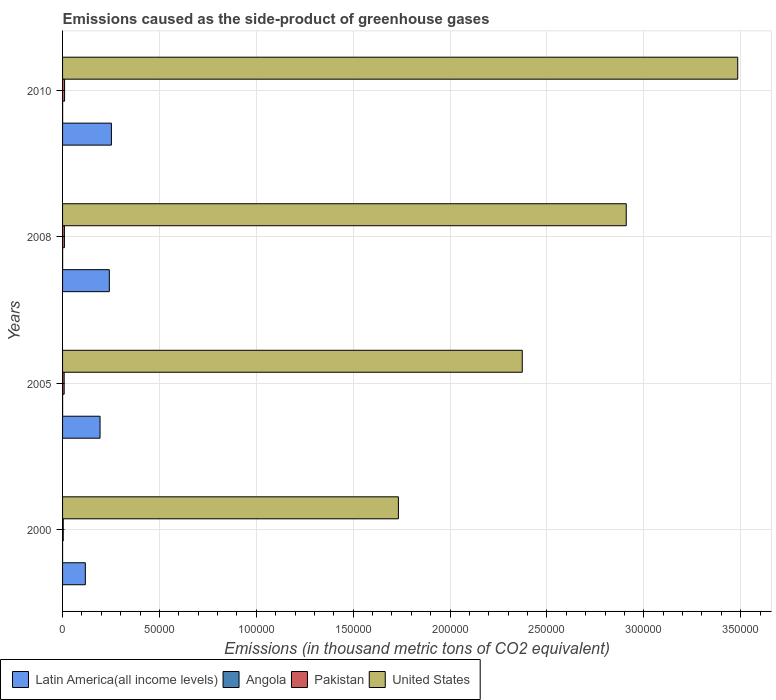What is the emissions caused as the side-product of greenhouse gases in Angola in 2005?
Your response must be concise. 19.3. Across all years, what is the maximum emissions caused as the side-product of greenhouse gases in Latin America(all income levels)?
Make the answer very short. 2.52e+04. Across all years, what is the minimum emissions caused as the side-product of greenhouse gases in Pakistan?
Your answer should be very brief. 347.2. In which year was the emissions caused as the side-product of greenhouse gases in Pakistan maximum?
Keep it short and to the point. 2010. In which year was the emissions caused as the side-product of greenhouse gases in Pakistan minimum?
Ensure brevity in your answer.  2000. What is the total emissions caused as the side-product of greenhouse gases in Pakistan in the graph?
Your answer should be compact. 3154.2. What is the difference between the emissions caused as the side-product of greenhouse gases in United States in 2005 and that in 2008?
Give a very brief answer. -5.37e+04. What is the difference between the emissions caused as the side-product of greenhouse gases in Angola in 2000 and the emissions caused as the side-product of greenhouse gases in Pakistan in 2008?
Your answer should be compact. -950.9. What is the average emissions caused as the side-product of greenhouse gases in Latin America(all income levels) per year?
Your answer should be compact. 2.01e+04. In the year 2000, what is the difference between the emissions caused as the side-product of greenhouse gases in Latin America(all income levels) and emissions caused as the side-product of greenhouse gases in United States?
Ensure brevity in your answer.  -1.62e+05. In how many years, is the emissions caused as the side-product of greenhouse gases in Pakistan greater than 320000 thousand metric tons?
Offer a terse response. 0. What is the ratio of the emissions caused as the side-product of greenhouse gases in Angola in 2000 to that in 2008?
Keep it short and to the point. 0.03. What is the difference between the highest and the second highest emissions caused as the side-product of greenhouse gases in Pakistan?
Ensure brevity in your answer.  84.4. What is the difference between the highest and the lowest emissions caused as the side-product of greenhouse gases in Pakistan?
Your answer should be very brief. 688.8. Is it the case that in every year, the sum of the emissions caused as the side-product of greenhouse gases in Angola and emissions caused as the side-product of greenhouse gases in Latin America(all income levels) is greater than the sum of emissions caused as the side-product of greenhouse gases in Pakistan and emissions caused as the side-product of greenhouse gases in United States?
Offer a very short reply. No. What does the 1st bar from the top in 2010 represents?
Your response must be concise. United States. What does the 4th bar from the bottom in 2010 represents?
Give a very brief answer. United States. How many bars are there?
Your response must be concise. 16. How many years are there in the graph?
Give a very brief answer. 4. What is the difference between two consecutive major ticks on the X-axis?
Your answer should be compact. 5.00e+04. Does the graph contain any zero values?
Make the answer very short. No. Does the graph contain grids?
Provide a succinct answer. Yes. How are the legend labels stacked?
Provide a succinct answer. Horizontal. What is the title of the graph?
Your answer should be very brief. Emissions caused as the side-product of greenhouse gases. What is the label or title of the X-axis?
Your response must be concise. Emissions (in thousand metric tons of CO2 equivalent). What is the label or title of the Y-axis?
Your answer should be very brief. Years. What is the Emissions (in thousand metric tons of CO2 equivalent) of Latin America(all income levels) in 2000?
Your answer should be compact. 1.18e+04. What is the Emissions (in thousand metric tons of CO2 equivalent) in Pakistan in 2000?
Provide a short and direct response. 347.2. What is the Emissions (in thousand metric tons of CO2 equivalent) of United States in 2000?
Your answer should be compact. 1.73e+05. What is the Emissions (in thousand metric tons of CO2 equivalent) in Latin America(all income levels) in 2005?
Keep it short and to the point. 1.93e+04. What is the Emissions (in thousand metric tons of CO2 equivalent) of Angola in 2005?
Provide a succinct answer. 19.3. What is the Emissions (in thousand metric tons of CO2 equivalent) in Pakistan in 2005?
Give a very brief answer. 819.4. What is the Emissions (in thousand metric tons of CO2 equivalent) in United States in 2005?
Provide a short and direct response. 2.37e+05. What is the Emissions (in thousand metric tons of CO2 equivalent) of Latin America(all income levels) in 2008?
Ensure brevity in your answer.  2.41e+04. What is the Emissions (in thousand metric tons of CO2 equivalent) in Pakistan in 2008?
Offer a very short reply. 951.6. What is the Emissions (in thousand metric tons of CO2 equivalent) in United States in 2008?
Ensure brevity in your answer.  2.91e+05. What is the Emissions (in thousand metric tons of CO2 equivalent) of Latin America(all income levels) in 2010?
Provide a succinct answer. 2.52e+04. What is the Emissions (in thousand metric tons of CO2 equivalent) in Pakistan in 2010?
Your response must be concise. 1036. What is the Emissions (in thousand metric tons of CO2 equivalent) in United States in 2010?
Your answer should be very brief. 3.48e+05. Across all years, what is the maximum Emissions (in thousand metric tons of CO2 equivalent) in Latin America(all income levels)?
Give a very brief answer. 2.52e+04. Across all years, what is the maximum Emissions (in thousand metric tons of CO2 equivalent) in Pakistan?
Ensure brevity in your answer.  1036. Across all years, what is the maximum Emissions (in thousand metric tons of CO2 equivalent) of United States?
Keep it short and to the point. 3.48e+05. Across all years, what is the minimum Emissions (in thousand metric tons of CO2 equivalent) of Latin America(all income levels)?
Your answer should be very brief. 1.18e+04. Across all years, what is the minimum Emissions (in thousand metric tons of CO2 equivalent) in Pakistan?
Your answer should be very brief. 347.2. Across all years, what is the minimum Emissions (in thousand metric tons of CO2 equivalent) in United States?
Make the answer very short. 1.73e+05. What is the total Emissions (in thousand metric tons of CO2 equivalent) of Latin America(all income levels) in the graph?
Provide a short and direct response. 8.04e+04. What is the total Emissions (in thousand metric tons of CO2 equivalent) of Angola in the graph?
Give a very brief answer. 77.5. What is the total Emissions (in thousand metric tons of CO2 equivalent) in Pakistan in the graph?
Ensure brevity in your answer.  3154.2. What is the total Emissions (in thousand metric tons of CO2 equivalent) of United States in the graph?
Give a very brief answer. 1.05e+06. What is the difference between the Emissions (in thousand metric tons of CO2 equivalent) of Latin America(all income levels) in 2000 and that in 2005?
Ensure brevity in your answer.  -7590.8. What is the difference between the Emissions (in thousand metric tons of CO2 equivalent) of Angola in 2000 and that in 2005?
Offer a terse response. -18.6. What is the difference between the Emissions (in thousand metric tons of CO2 equivalent) in Pakistan in 2000 and that in 2005?
Provide a short and direct response. -472.2. What is the difference between the Emissions (in thousand metric tons of CO2 equivalent) in United States in 2000 and that in 2005?
Offer a terse response. -6.39e+04. What is the difference between the Emissions (in thousand metric tons of CO2 equivalent) of Latin America(all income levels) in 2000 and that in 2008?
Keep it short and to the point. -1.24e+04. What is the difference between the Emissions (in thousand metric tons of CO2 equivalent) of Angola in 2000 and that in 2008?
Give a very brief answer. -25.8. What is the difference between the Emissions (in thousand metric tons of CO2 equivalent) in Pakistan in 2000 and that in 2008?
Provide a short and direct response. -604.4. What is the difference between the Emissions (in thousand metric tons of CO2 equivalent) in United States in 2000 and that in 2008?
Your response must be concise. -1.18e+05. What is the difference between the Emissions (in thousand metric tons of CO2 equivalent) in Latin America(all income levels) in 2000 and that in 2010?
Your answer should be compact. -1.34e+04. What is the difference between the Emissions (in thousand metric tons of CO2 equivalent) of Angola in 2000 and that in 2010?
Give a very brief answer. -30.3. What is the difference between the Emissions (in thousand metric tons of CO2 equivalent) of Pakistan in 2000 and that in 2010?
Your answer should be very brief. -688.8. What is the difference between the Emissions (in thousand metric tons of CO2 equivalent) in United States in 2000 and that in 2010?
Offer a terse response. -1.75e+05. What is the difference between the Emissions (in thousand metric tons of CO2 equivalent) of Latin America(all income levels) in 2005 and that in 2008?
Offer a very short reply. -4793.3. What is the difference between the Emissions (in thousand metric tons of CO2 equivalent) in Angola in 2005 and that in 2008?
Give a very brief answer. -7.2. What is the difference between the Emissions (in thousand metric tons of CO2 equivalent) in Pakistan in 2005 and that in 2008?
Give a very brief answer. -132.2. What is the difference between the Emissions (in thousand metric tons of CO2 equivalent) in United States in 2005 and that in 2008?
Offer a terse response. -5.37e+04. What is the difference between the Emissions (in thousand metric tons of CO2 equivalent) of Latin America(all income levels) in 2005 and that in 2010?
Provide a short and direct response. -5858.9. What is the difference between the Emissions (in thousand metric tons of CO2 equivalent) of Angola in 2005 and that in 2010?
Keep it short and to the point. -11.7. What is the difference between the Emissions (in thousand metric tons of CO2 equivalent) in Pakistan in 2005 and that in 2010?
Offer a terse response. -216.6. What is the difference between the Emissions (in thousand metric tons of CO2 equivalent) of United States in 2005 and that in 2010?
Your answer should be compact. -1.11e+05. What is the difference between the Emissions (in thousand metric tons of CO2 equivalent) of Latin America(all income levels) in 2008 and that in 2010?
Your response must be concise. -1065.6. What is the difference between the Emissions (in thousand metric tons of CO2 equivalent) of Angola in 2008 and that in 2010?
Make the answer very short. -4.5. What is the difference between the Emissions (in thousand metric tons of CO2 equivalent) in Pakistan in 2008 and that in 2010?
Give a very brief answer. -84.4. What is the difference between the Emissions (in thousand metric tons of CO2 equivalent) in United States in 2008 and that in 2010?
Your answer should be very brief. -5.75e+04. What is the difference between the Emissions (in thousand metric tons of CO2 equivalent) in Latin America(all income levels) in 2000 and the Emissions (in thousand metric tons of CO2 equivalent) in Angola in 2005?
Your answer should be compact. 1.17e+04. What is the difference between the Emissions (in thousand metric tons of CO2 equivalent) of Latin America(all income levels) in 2000 and the Emissions (in thousand metric tons of CO2 equivalent) of Pakistan in 2005?
Give a very brief answer. 1.09e+04. What is the difference between the Emissions (in thousand metric tons of CO2 equivalent) in Latin America(all income levels) in 2000 and the Emissions (in thousand metric tons of CO2 equivalent) in United States in 2005?
Give a very brief answer. -2.25e+05. What is the difference between the Emissions (in thousand metric tons of CO2 equivalent) in Angola in 2000 and the Emissions (in thousand metric tons of CO2 equivalent) in Pakistan in 2005?
Offer a very short reply. -818.7. What is the difference between the Emissions (in thousand metric tons of CO2 equivalent) in Angola in 2000 and the Emissions (in thousand metric tons of CO2 equivalent) in United States in 2005?
Give a very brief answer. -2.37e+05. What is the difference between the Emissions (in thousand metric tons of CO2 equivalent) of Pakistan in 2000 and the Emissions (in thousand metric tons of CO2 equivalent) of United States in 2005?
Make the answer very short. -2.37e+05. What is the difference between the Emissions (in thousand metric tons of CO2 equivalent) of Latin America(all income levels) in 2000 and the Emissions (in thousand metric tons of CO2 equivalent) of Angola in 2008?
Your answer should be very brief. 1.17e+04. What is the difference between the Emissions (in thousand metric tons of CO2 equivalent) of Latin America(all income levels) in 2000 and the Emissions (in thousand metric tons of CO2 equivalent) of Pakistan in 2008?
Your response must be concise. 1.08e+04. What is the difference between the Emissions (in thousand metric tons of CO2 equivalent) in Latin America(all income levels) in 2000 and the Emissions (in thousand metric tons of CO2 equivalent) in United States in 2008?
Provide a succinct answer. -2.79e+05. What is the difference between the Emissions (in thousand metric tons of CO2 equivalent) of Angola in 2000 and the Emissions (in thousand metric tons of CO2 equivalent) of Pakistan in 2008?
Give a very brief answer. -950.9. What is the difference between the Emissions (in thousand metric tons of CO2 equivalent) in Angola in 2000 and the Emissions (in thousand metric tons of CO2 equivalent) in United States in 2008?
Give a very brief answer. -2.91e+05. What is the difference between the Emissions (in thousand metric tons of CO2 equivalent) in Pakistan in 2000 and the Emissions (in thousand metric tons of CO2 equivalent) in United States in 2008?
Provide a succinct answer. -2.91e+05. What is the difference between the Emissions (in thousand metric tons of CO2 equivalent) of Latin America(all income levels) in 2000 and the Emissions (in thousand metric tons of CO2 equivalent) of Angola in 2010?
Ensure brevity in your answer.  1.17e+04. What is the difference between the Emissions (in thousand metric tons of CO2 equivalent) of Latin America(all income levels) in 2000 and the Emissions (in thousand metric tons of CO2 equivalent) of Pakistan in 2010?
Your response must be concise. 1.07e+04. What is the difference between the Emissions (in thousand metric tons of CO2 equivalent) of Latin America(all income levels) in 2000 and the Emissions (in thousand metric tons of CO2 equivalent) of United States in 2010?
Keep it short and to the point. -3.37e+05. What is the difference between the Emissions (in thousand metric tons of CO2 equivalent) in Angola in 2000 and the Emissions (in thousand metric tons of CO2 equivalent) in Pakistan in 2010?
Ensure brevity in your answer.  -1035.3. What is the difference between the Emissions (in thousand metric tons of CO2 equivalent) in Angola in 2000 and the Emissions (in thousand metric tons of CO2 equivalent) in United States in 2010?
Keep it short and to the point. -3.48e+05. What is the difference between the Emissions (in thousand metric tons of CO2 equivalent) of Pakistan in 2000 and the Emissions (in thousand metric tons of CO2 equivalent) of United States in 2010?
Provide a succinct answer. -3.48e+05. What is the difference between the Emissions (in thousand metric tons of CO2 equivalent) of Latin America(all income levels) in 2005 and the Emissions (in thousand metric tons of CO2 equivalent) of Angola in 2008?
Provide a short and direct response. 1.93e+04. What is the difference between the Emissions (in thousand metric tons of CO2 equivalent) of Latin America(all income levels) in 2005 and the Emissions (in thousand metric tons of CO2 equivalent) of Pakistan in 2008?
Your response must be concise. 1.84e+04. What is the difference between the Emissions (in thousand metric tons of CO2 equivalent) of Latin America(all income levels) in 2005 and the Emissions (in thousand metric tons of CO2 equivalent) of United States in 2008?
Provide a short and direct response. -2.72e+05. What is the difference between the Emissions (in thousand metric tons of CO2 equivalent) of Angola in 2005 and the Emissions (in thousand metric tons of CO2 equivalent) of Pakistan in 2008?
Your answer should be compact. -932.3. What is the difference between the Emissions (in thousand metric tons of CO2 equivalent) in Angola in 2005 and the Emissions (in thousand metric tons of CO2 equivalent) in United States in 2008?
Offer a very short reply. -2.91e+05. What is the difference between the Emissions (in thousand metric tons of CO2 equivalent) in Pakistan in 2005 and the Emissions (in thousand metric tons of CO2 equivalent) in United States in 2008?
Provide a succinct answer. -2.90e+05. What is the difference between the Emissions (in thousand metric tons of CO2 equivalent) in Latin America(all income levels) in 2005 and the Emissions (in thousand metric tons of CO2 equivalent) in Angola in 2010?
Your response must be concise. 1.93e+04. What is the difference between the Emissions (in thousand metric tons of CO2 equivalent) in Latin America(all income levels) in 2005 and the Emissions (in thousand metric tons of CO2 equivalent) in Pakistan in 2010?
Your response must be concise. 1.83e+04. What is the difference between the Emissions (in thousand metric tons of CO2 equivalent) of Latin America(all income levels) in 2005 and the Emissions (in thousand metric tons of CO2 equivalent) of United States in 2010?
Keep it short and to the point. -3.29e+05. What is the difference between the Emissions (in thousand metric tons of CO2 equivalent) in Angola in 2005 and the Emissions (in thousand metric tons of CO2 equivalent) in Pakistan in 2010?
Give a very brief answer. -1016.7. What is the difference between the Emissions (in thousand metric tons of CO2 equivalent) of Angola in 2005 and the Emissions (in thousand metric tons of CO2 equivalent) of United States in 2010?
Provide a short and direct response. -3.48e+05. What is the difference between the Emissions (in thousand metric tons of CO2 equivalent) of Pakistan in 2005 and the Emissions (in thousand metric tons of CO2 equivalent) of United States in 2010?
Your response must be concise. -3.48e+05. What is the difference between the Emissions (in thousand metric tons of CO2 equivalent) of Latin America(all income levels) in 2008 and the Emissions (in thousand metric tons of CO2 equivalent) of Angola in 2010?
Offer a terse response. 2.41e+04. What is the difference between the Emissions (in thousand metric tons of CO2 equivalent) of Latin America(all income levels) in 2008 and the Emissions (in thousand metric tons of CO2 equivalent) of Pakistan in 2010?
Your response must be concise. 2.31e+04. What is the difference between the Emissions (in thousand metric tons of CO2 equivalent) in Latin America(all income levels) in 2008 and the Emissions (in thousand metric tons of CO2 equivalent) in United States in 2010?
Your answer should be compact. -3.24e+05. What is the difference between the Emissions (in thousand metric tons of CO2 equivalent) in Angola in 2008 and the Emissions (in thousand metric tons of CO2 equivalent) in Pakistan in 2010?
Offer a terse response. -1009.5. What is the difference between the Emissions (in thousand metric tons of CO2 equivalent) of Angola in 2008 and the Emissions (in thousand metric tons of CO2 equivalent) of United States in 2010?
Your response must be concise. -3.48e+05. What is the difference between the Emissions (in thousand metric tons of CO2 equivalent) in Pakistan in 2008 and the Emissions (in thousand metric tons of CO2 equivalent) in United States in 2010?
Offer a very short reply. -3.48e+05. What is the average Emissions (in thousand metric tons of CO2 equivalent) in Latin America(all income levels) per year?
Make the answer very short. 2.01e+04. What is the average Emissions (in thousand metric tons of CO2 equivalent) in Angola per year?
Make the answer very short. 19.38. What is the average Emissions (in thousand metric tons of CO2 equivalent) in Pakistan per year?
Keep it short and to the point. 788.55. What is the average Emissions (in thousand metric tons of CO2 equivalent) of United States per year?
Your answer should be compact. 2.62e+05. In the year 2000, what is the difference between the Emissions (in thousand metric tons of CO2 equivalent) of Latin America(all income levels) and Emissions (in thousand metric tons of CO2 equivalent) of Angola?
Provide a short and direct response. 1.18e+04. In the year 2000, what is the difference between the Emissions (in thousand metric tons of CO2 equivalent) in Latin America(all income levels) and Emissions (in thousand metric tons of CO2 equivalent) in Pakistan?
Provide a short and direct response. 1.14e+04. In the year 2000, what is the difference between the Emissions (in thousand metric tons of CO2 equivalent) of Latin America(all income levels) and Emissions (in thousand metric tons of CO2 equivalent) of United States?
Keep it short and to the point. -1.62e+05. In the year 2000, what is the difference between the Emissions (in thousand metric tons of CO2 equivalent) in Angola and Emissions (in thousand metric tons of CO2 equivalent) in Pakistan?
Provide a succinct answer. -346.5. In the year 2000, what is the difference between the Emissions (in thousand metric tons of CO2 equivalent) in Angola and Emissions (in thousand metric tons of CO2 equivalent) in United States?
Make the answer very short. -1.73e+05. In the year 2000, what is the difference between the Emissions (in thousand metric tons of CO2 equivalent) in Pakistan and Emissions (in thousand metric tons of CO2 equivalent) in United States?
Give a very brief answer. -1.73e+05. In the year 2005, what is the difference between the Emissions (in thousand metric tons of CO2 equivalent) in Latin America(all income levels) and Emissions (in thousand metric tons of CO2 equivalent) in Angola?
Ensure brevity in your answer.  1.93e+04. In the year 2005, what is the difference between the Emissions (in thousand metric tons of CO2 equivalent) of Latin America(all income levels) and Emissions (in thousand metric tons of CO2 equivalent) of Pakistan?
Provide a succinct answer. 1.85e+04. In the year 2005, what is the difference between the Emissions (in thousand metric tons of CO2 equivalent) of Latin America(all income levels) and Emissions (in thousand metric tons of CO2 equivalent) of United States?
Provide a succinct answer. -2.18e+05. In the year 2005, what is the difference between the Emissions (in thousand metric tons of CO2 equivalent) of Angola and Emissions (in thousand metric tons of CO2 equivalent) of Pakistan?
Your answer should be compact. -800.1. In the year 2005, what is the difference between the Emissions (in thousand metric tons of CO2 equivalent) of Angola and Emissions (in thousand metric tons of CO2 equivalent) of United States?
Offer a terse response. -2.37e+05. In the year 2005, what is the difference between the Emissions (in thousand metric tons of CO2 equivalent) of Pakistan and Emissions (in thousand metric tons of CO2 equivalent) of United States?
Your answer should be compact. -2.36e+05. In the year 2008, what is the difference between the Emissions (in thousand metric tons of CO2 equivalent) in Latin America(all income levels) and Emissions (in thousand metric tons of CO2 equivalent) in Angola?
Offer a very short reply. 2.41e+04. In the year 2008, what is the difference between the Emissions (in thousand metric tons of CO2 equivalent) in Latin America(all income levels) and Emissions (in thousand metric tons of CO2 equivalent) in Pakistan?
Your response must be concise. 2.32e+04. In the year 2008, what is the difference between the Emissions (in thousand metric tons of CO2 equivalent) of Latin America(all income levels) and Emissions (in thousand metric tons of CO2 equivalent) of United States?
Provide a short and direct response. -2.67e+05. In the year 2008, what is the difference between the Emissions (in thousand metric tons of CO2 equivalent) of Angola and Emissions (in thousand metric tons of CO2 equivalent) of Pakistan?
Your answer should be compact. -925.1. In the year 2008, what is the difference between the Emissions (in thousand metric tons of CO2 equivalent) in Angola and Emissions (in thousand metric tons of CO2 equivalent) in United States?
Offer a terse response. -2.91e+05. In the year 2008, what is the difference between the Emissions (in thousand metric tons of CO2 equivalent) in Pakistan and Emissions (in thousand metric tons of CO2 equivalent) in United States?
Offer a terse response. -2.90e+05. In the year 2010, what is the difference between the Emissions (in thousand metric tons of CO2 equivalent) of Latin America(all income levels) and Emissions (in thousand metric tons of CO2 equivalent) of Angola?
Keep it short and to the point. 2.52e+04. In the year 2010, what is the difference between the Emissions (in thousand metric tons of CO2 equivalent) in Latin America(all income levels) and Emissions (in thousand metric tons of CO2 equivalent) in Pakistan?
Your answer should be very brief. 2.42e+04. In the year 2010, what is the difference between the Emissions (in thousand metric tons of CO2 equivalent) of Latin America(all income levels) and Emissions (in thousand metric tons of CO2 equivalent) of United States?
Make the answer very short. -3.23e+05. In the year 2010, what is the difference between the Emissions (in thousand metric tons of CO2 equivalent) in Angola and Emissions (in thousand metric tons of CO2 equivalent) in Pakistan?
Your response must be concise. -1005. In the year 2010, what is the difference between the Emissions (in thousand metric tons of CO2 equivalent) in Angola and Emissions (in thousand metric tons of CO2 equivalent) in United States?
Give a very brief answer. -3.48e+05. In the year 2010, what is the difference between the Emissions (in thousand metric tons of CO2 equivalent) in Pakistan and Emissions (in thousand metric tons of CO2 equivalent) in United States?
Offer a very short reply. -3.47e+05. What is the ratio of the Emissions (in thousand metric tons of CO2 equivalent) in Latin America(all income levels) in 2000 to that in 2005?
Provide a short and direct response. 0.61. What is the ratio of the Emissions (in thousand metric tons of CO2 equivalent) of Angola in 2000 to that in 2005?
Ensure brevity in your answer.  0.04. What is the ratio of the Emissions (in thousand metric tons of CO2 equivalent) in Pakistan in 2000 to that in 2005?
Ensure brevity in your answer.  0.42. What is the ratio of the Emissions (in thousand metric tons of CO2 equivalent) in United States in 2000 to that in 2005?
Offer a terse response. 0.73. What is the ratio of the Emissions (in thousand metric tons of CO2 equivalent) of Latin America(all income levels) in 2000 to that in 2008?
Provide a short and direct response. 0.49. What is the ratio of the Emissions (in thousand metric tons of CO2 equivalent) in Angola in 2000 to that in 2008?
Give a very brief answer. 0.03. What is the ratio of the Emissions (in thousand metric tons of CO2 equivalent) in Pakistan in 2000 to that in 2008?
Ensure brevity in your answer.  0.36. What is the ratio of the Emissions (in thousand metric tons of CO2 equivalent) of United States in 2000 to that in 2008?
Make the answer very short. 0.6. What is the ratio of the Emissions (in thousand metric tons of CO2 equivalent) of Latin America(all income levels) in 2000 to that in 2010?
Your answer should be very brief. 0.47. What is the ratio of the Emissions (in thousand metric tons of CO2 equivalent) of Angola in 2000 to that in 2010?
Make the answer very short. 0.02. What is the ratio of the Emissions (in thousand metric tons of CO2 equivalent) of Pakistan in 2000 to that in 2010?
Ensure brevity in your answer.  0.34. What is the ratio of the Emissions (in thousand metric tons of CO2 equivalent) in United States in 2000 to that in 2010?
Keep it short and to the point. 0.5. What is the ratio of the Emissions (in thousand metric tons of CO2 equivalent) in Latin America(all income levels) in 2005 to that in 2008?
Provide a short and direct response. 0.8. What is the ratio of the Emissions (in thousand metric tons of CO2 equivalent) of Angola in 2005 to that in 2008?
Make the answer very short. 0.73. What is the ratio of the Emissions (in thousand metric tons of CO2 equivalent) in Pakistan in 2005 to that in 2008?
Keep it short and to the point. 0.86. What is the ratio of the Emissions (in thousand metric tons of CO2 equivalent) of United States in 2005 to that in 2008?
Make the answer very short. 0.82. What is the ratio of the Emissions (in thousand metric tons of CO2 equivalent) in Latin America(all income levels) in 2005 to that in 2010?
Provide a succinct answer. 0.77. What is the ratio of the Emissions (in thousand metric tons of CO2 equivalent) of Angola in 2005 to that in 2010?
Provide a short and direct response. 0.62. What is the ratio of the Emissions (in thousand metric tons of CO2 equivalent) in Pakistan in 2005 to that in 2010?
Give a very brief answer. 0.79. What is the ratio of the Emissions (in thousand metric tons of CO2 equivalent) of United States in 2005 to that in 2010?
Offer a terse response. 0.68. What is the ratio of the Emissions (in thousand metric tons of CO2 equivalent) of Latin America(all income levels) in 2008 to that in 2010?
Ensure brevity in your answer.  0.96. What is the ratio of the Emissions (in thousand metric tons of CO2 equivalent) of Angola in 2008 to that in 2010?
Ensure brevity in your answer.  0.85. What is the ratio of the Emissions (in thousand metric tons of CO2 equivalent) in Pakistan in 2008 to that in 2010?
Offer a very short reply. 0.92. What is the ratio of the Emissions (in thousand metric tons of CO2 equivalent) in United States in 2008 to that in 2010?
Keep it short and to the point. 0.83. What is the difference between the highest and the second highest Emissions (in thousand metric tons of CO2 equivalent) in Latin America(all income levels)?
Offer a very short reply. 1065.6. What is the difference between the highest and the second highest Emissions (in thousand metric tons of CO2 equivalent) in Angola?
Offer a very short reply. 4.5. What is the difference between the highest and the second highest Emissions (in thousand metric tons of CO2 equivalent) in Pakistan?
Your response must be concise. 84.4. What is the difference between the highest and the second highest Emissions (in thousand metric tons of CO2 equivalent) of United States?
Your answer should be compact. 5.75e+04. What is the difference between the highest and the lowest Emissions (in thousand metric tons of CO2 equivalent) of Latin America(all income levels)?
Your answer should be very brief. 1.34e+04. What is the difference between the highest and the lowest Emissions (in thousand metric tons of CO2 equivalent) in Angola?
Your answer should be very brief. 30.3. What is the difference between the highest and the lowest Emissions (in thousand metric tons of CO2 equivalent) of Pakistan?
Your answer should be compact. 688.8. What is the difference between the highest and the lowest Emissions (in thousand metric tons of CO2 equivalent) in United States?
Provide a short and direct response. 1.75e+05. 